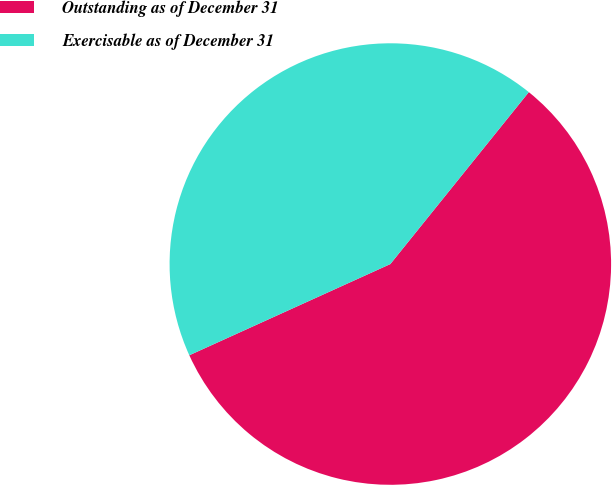Convert chart to OTSL. <chart><loc_0><loc_0><loc_500><loc_500><pie_chart><fcel>Outstanding as of December 31<fcel>Exercisable as of December 31<nl><fcel>57.43%<fcel>42.57%<nl></chart> 